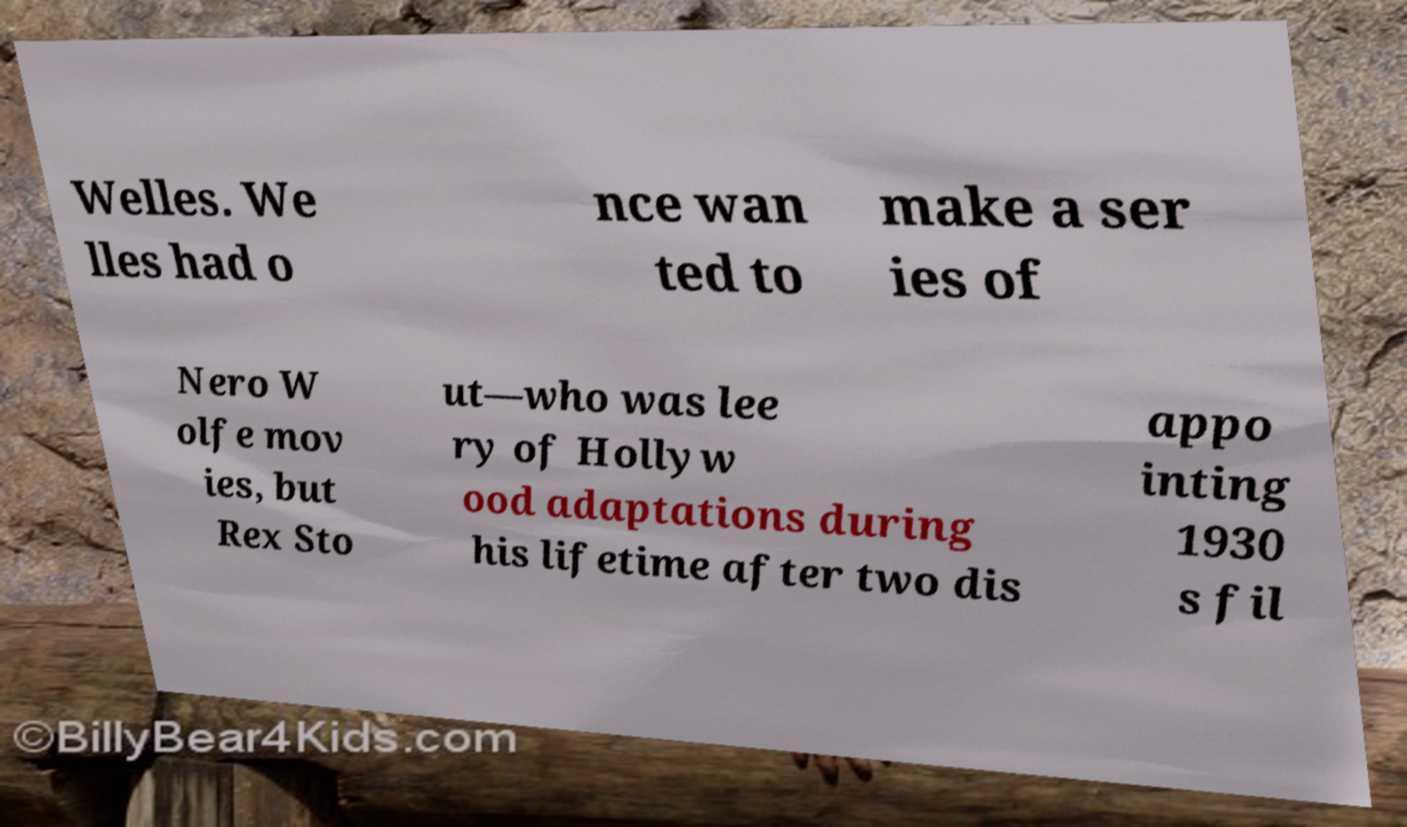Can you read and provide the text displayed in the image?This photo seems to have some interesting text. Can you extract and type it out for me? Welles. We lles had o nce wan ted to make a ser ies of Nero W olfe mov ies, but Rex Sto ut—who was lee ry of Hollyw ood adaptations during his lifetime after two dis appo inting 1930 s fil 